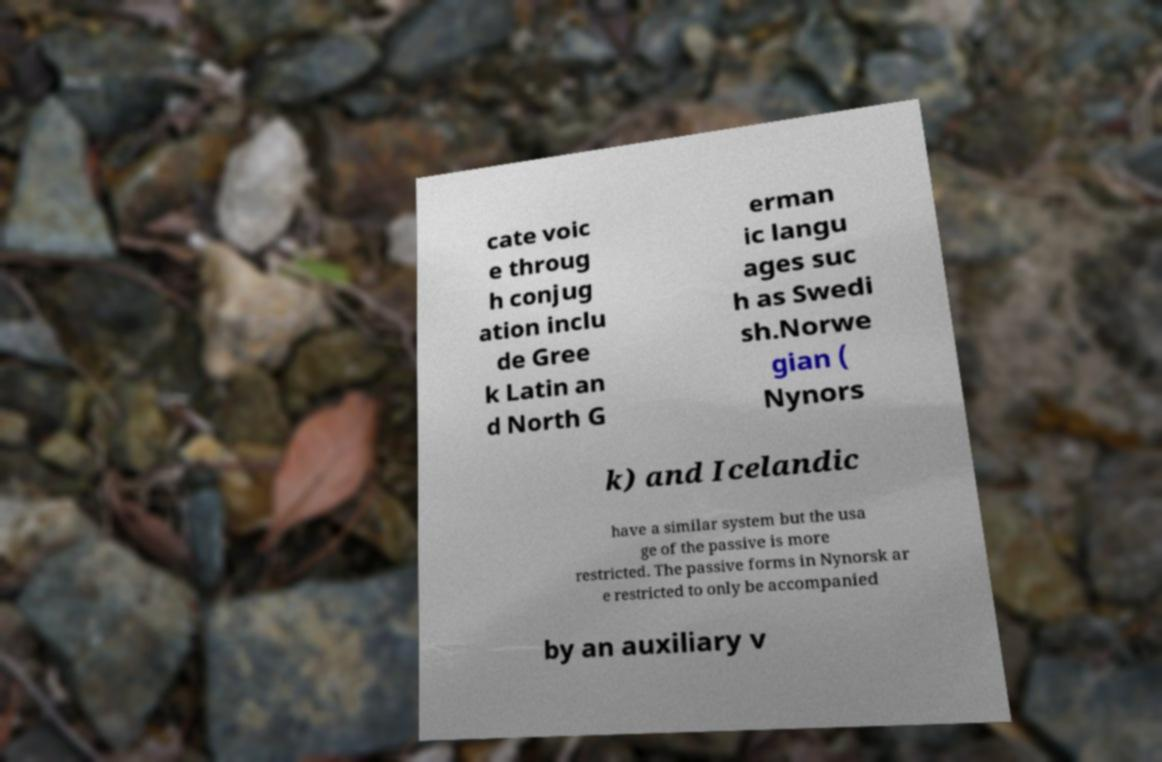Can you accurately transcribe the text from the provided image for me? cate voic e throug h conjug ation inclu de Gree k Latin an d North G erman ic langu ages suc h as Swedi sh.Norwe gian ( Nynors k) and Icelandic have a similar system but the usa ge of the passive is more restricted. The passive forms in Nynorsk ar e restricted to only be accompanied by an auxiliary v 